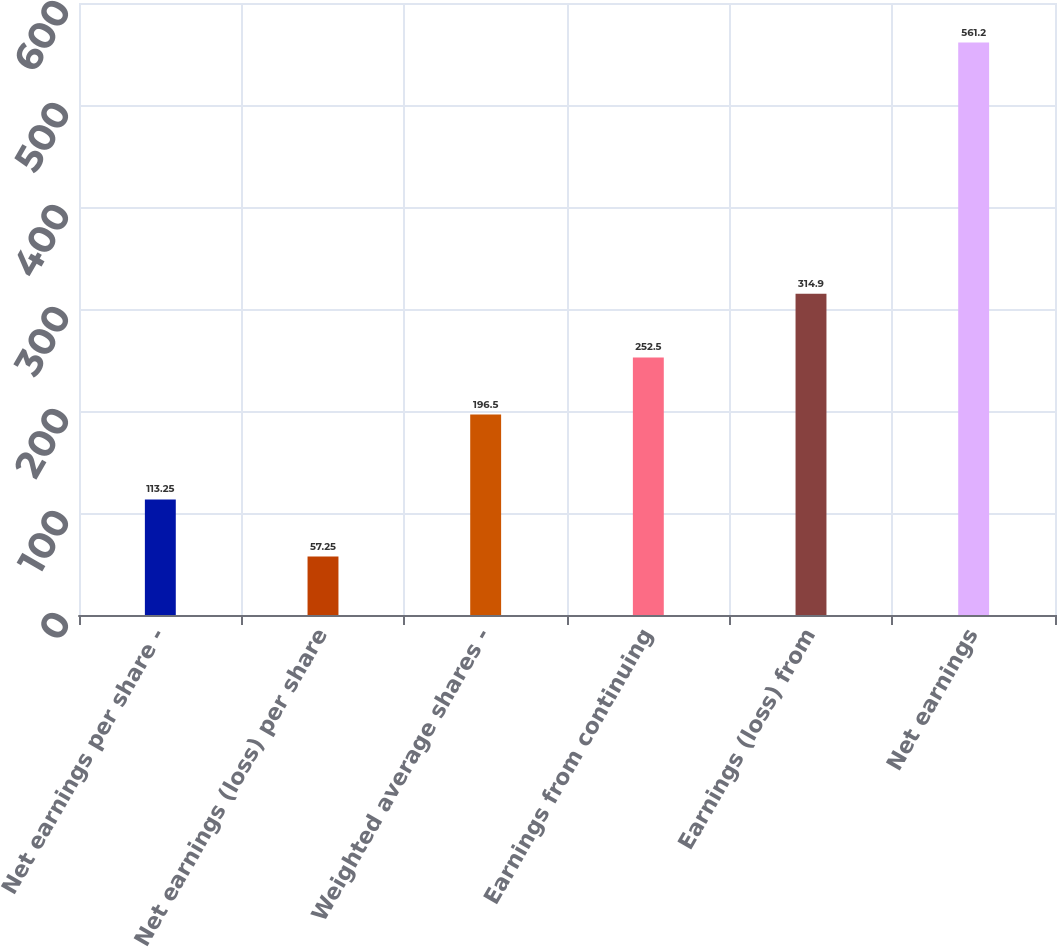<chart> <loc_0><loc_0><loc_500><loc_500><bar_chart><fcel>Net earnings per share -<fcel>Net earnings (loss) per share<fcel>Weighted average shares -<fcel>Earnings from continuing<fcel>Earnings (loss) from<fcel>Net earnings<nl><fcel>113.25<fcel>57.25<fcel>196.5<fcel>252.5<fcel>314.9<fcel>561.2<nl></chart> 